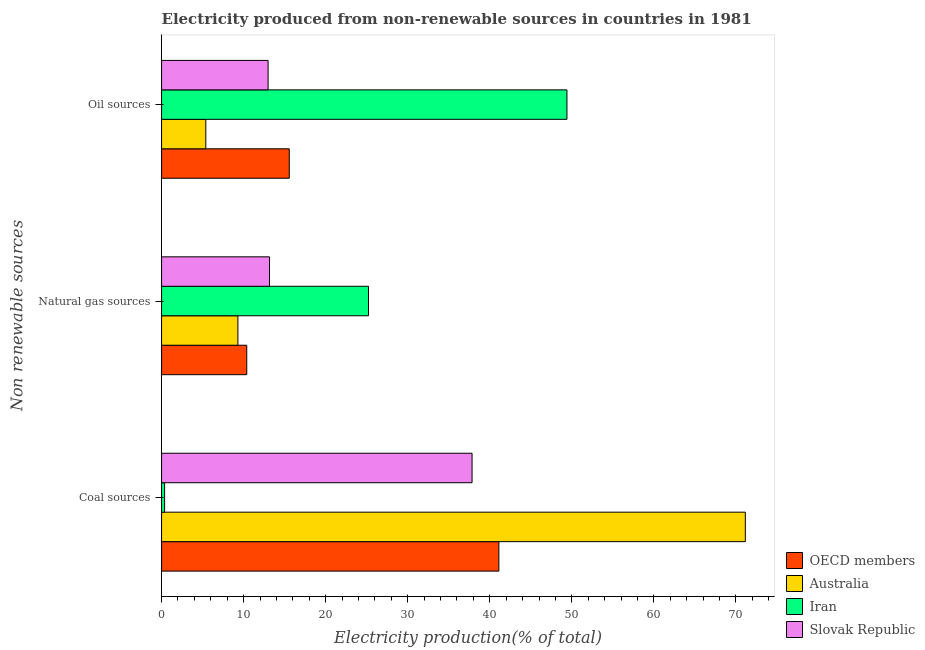How many different coloured bars are there?
Provide a succinct answer. 4. How many groups of bars are there?
Provide a short and direct response. 3. Are the number of bars on each tick of the Y-axis equal?
Ensure brevity in your answer.  Yes. What is the label of the 1st group of bars from the top?
Your answer should be compact. Oil sources. What is the percentage of electricity produced by coal in Slovak Republic?
Keep it short and to the point. 37.84. Across all countries, what is the maximum percentage of electricity produced by oil sources?
Provide a succinct answer. 49.4. Across all countries, what is the minimum percentage of electricity produced by oil sources?
Make the answer very short. 5.39. In which country was the percentage of electricity produced by coal maximum?
Ensure brevity in your answer.  Australia. In which country was the percentage of electricity produced by coal minimum?
Offer a terse response. Iran. What is the total percentage of electricity produced by coal in the graph?
Your answer should be compact. 150.45. What is the difference between the percentage of electricity produced by oil sources in OECD members and that in Australia?
Your answer should be compact. 10.17. What is the difference between the percentage of electricity produced by coal in OECD members and the percentage of electricity produced by natural gas in Australia?
Keep it short and to the point. 31.8. What is the average percentage of electricity produced by natural gas per country?
Give a very brief answer. 14.51. What is the difference between the percentage of electricity produced by oil sources and percentage of electricity produced by natural gas in Slovak Republic?
Keep it short and to the point. -0.17. What is the ratio of the percentage of electricity produced by coal in OECD members to that in Slovak Republic?
Your response must be concise. 1.09. Is the percentage of electricity produced by coal in Slovak Republic less than that in Iran?
Your answer should be very brief. No. What is the difference between the highest and the second highest percentage of electricity produced by oil sources?
Offer a terse response. 33.84. What is the difference between the highest and the lowest percentage of electricity produced by natural gas?
Offer a very short reply. 15.92. How many bars are there?
Make the answer very short. 12. Are all the bars in the graph horizontal?
Offer a terse response. Yes. How many countries are there in the graph?
Your answer should be very brief. 4. Does the graph contain any zero values?
Provide a succinct answer. No. Where does the legend appear in the graph?
Offer a very short reply. Bottom right. How many legend labels are there?
Your answer should be very brief. 4. What is the title of the graph?
Offer a very short reply. Electricity produced from non-renewable sources in countries in 1981. Does "Ethiopia" appear as one of the legend labels in the graph?
Your answer should be compact. No. What is the label or title of the Y-axis?
Your answer should be compact. Non renewable sources. What is the Electricity production(% of total) of OECD members in Coal sources?
Provide a succinct answer. 41.11. What is the Electricity production(% of total) in Australia in Coal sources?
Offer a terse response. 71.14. What is the Electricity production(% of total) of Iran in Coal sources?
Provide a short and direct response. 0.37. What is the Electricity production(% of total) in Slovak Republic in Coal sources?
Your response must be concise. 37.84. What is the Electricity production(% of total) in OECD members in Natural gas sources?
Your answer should be very brief. 10.38. What is the Electricity production(% of total) of Australia in Natural gas sources?
Provide a succinct answer. 9.3. What is the Electricity production(% of total) of Iran in Natural gas sources?
Offer a terse response. 25.22. What is the Electricity production(% of total) of Slovak Republic in Natural gas sources?
Offer a very short reply. 13.15. What is the Electricity production(% of total) in OECD members in Oil sources?
Provide a succinct answer. 15.56. What is the Electricity production(% of total) of Australia in Oil sources?
Offer a very short reply. 5.39. What is the Electricity production(% of total) of Iran in Oil sources?
Your answer should be very brief. 49.4. What is the Electricity production(% of total) of Slovak Republic in Oil sources?
Give a very brief answer. 12.98. Across all Non renewable sources, what is the maximum Electricity production(% of total) of OECD members?
Make the answer very short. 41.11. Across all Non renewable sources, what is the maximum Electricity production(% of total) in Australia?
Make the answer very short. 71.14. Across all Non renewable sources, what is the maximum Electricity production(% of total) of Iran?
Keep it short and to the point. 49.4. Across all Non renewable sources, what is the maximum Electricity production(% of total) in Slovak Republic?
Provide a short and direct response. 37.84. Across all Non renewable sources, what is the minimum Electricity production(% of total) of OECD members?
Offer a terse response. 10.38. Across all Non renewable sources, what is the minimum Electricity production(% of total) of Australia?
Provide a succinct answer. 5.39. Across all Non renewable sources, what is the minimum Electricity production(% of total) in Iran?
Make the answer very short. 0.37. Across all Non renewable sources, what is the minimum Electricity production(% of total) in Slovak Republic?
Provide a short and direct response. 12.98. What is the total Electricity production(% of total) of OECD members in the graph?
Ensure brevity in your answer.  67.05. What is the total Electricity production(% of total) in Australia in the graph?
Keep it short and to the point. 85.83. What is the total Electricity production(% of total) in Iran in the graph?
Offer a terse response. 74.99. What is the total Electricity production(% of total) of Slovak Republic in the graph?
Ensure brevity in your answer.  63.97. What is the difference between the Electricity production(% of total) in OECD members in Coal sources and that in Natural gas sources?
Provide a succinct answer. 30.72. What is the difference between the Electricity production(% of total) in Australia in Coal sources and that in Natural gas sources?
Your response must be concise. 61.84. What is the difference between the Electricity production(% of total) in Iran in Coal sources and that in Natural gas sources?
Keep it short and to the point. -24.85. What is the difference between the Electricity production(% of total) in Slovak Republic in Coal sources and that in Natural gas sources?
Ensure brevity in your answer.  24.68. What is the difference between the Electricity production(% of total) of OECD members in Coal sources and that in Oil sources?
Make the answer very short. 25.54. What is the difference between the Electricity production(% of total) of Australia in Coal sources and that in Oil sources?
Your answer should be very brief. 65.75. What is the difference between the Electricity production(% of total) in Iran in Coal sources and that in Oil sources?
Provide a succinct answer. -49.03. What is the difference between the Electricity production(% of total) in Slovak Republic in Coal sources and that in Oil sources?
Offer a terse response. 24.86. What is the difference between the Electricity production(% of total) in OECD members in Natural gas sources and that in Oil sources?
Provide a succinct answer. -5.18. What is the difference between the Electricity production(% of total) in Australia in Natural gas sources and that in Oil sources?
Keep it short and to the point. 3.91. What is the difference between the Electricity production(% of total) of Iran in Natural gas sources and that in Oil sources?
Your answer should be compact. -24.18. What is the difference between the Electricity production(% of total) in Slovak Republic in Natural gas sources and that in Oil sources?
Keep it short and to the point. 0.17. What is the difference between the Electricity production(% of total) in OECD members in Coal sources and the Electricity production(% of total) in Australia in Natural gas sources?
Make the answer very short. 31.8. What is the difference between the Electricity production(% of total) of OECD members in Coal sources and the Electricity production(% of total) of Iran in Natural gas sources?
Provide a succinct answer. 15.89. What is the difference between the Electricity production(% of total) in OECD members in Coal sources and the Electricity production(% of total) in Slovak Republic in Natural gas sources?
Provide a short and direct response. 27.95. What is the difference between the Electricity production(% of total) in Australia in Coal sources and the Electricity production(% of total) in Iran in Natural gas sources?
Make the answer very short. 45.92. What is the difference between the Electricity production(% of total) in Australia in Coal sources and the Electricity production(% of total) in Slovak Republic in Natural gas sources?
Your answer should be compact. 57.98. What is the difference between the Electricity production(% of total) in Iran in Coal sources and the Electricity production(% of total) in Slovak Republic in Natural gas sources?
Keep it short and to the point. -12.78. What is the difference between the Electricity production(% of total) in OECD members in Coal sources and the Electricity production(% of total) in Australia in Oil sources?
Provide a short and direct response. 35.71. What is the difference between the Electricity production(% of total) of OECD members in Coal sources and the Electricity production(% of total) of Iran in Oil sources?
Provide a succinct answer. -8.3. What is the difference between the Electricity production(% of total) in OECD members in Coal sources and the Electricity production(% of total) in Slovak Republic in Oil sources?
Your response must be concise. 28.12. What is the difference between the Electricity production(% of total) of Australia in Coal sources and the Electricity production(% of total) of Iran in Oil sources?
Your response must be concise. 21.74. What is the difference between the Electricity production(% of total) in Australia in Coal sources and the Electricity production(% of total) in Slovak Republic in Oil sources?
Keep it short and to the point. 58.16. What is the difference between the Electricity production(% of total) in Iran in Coal sources and the Electricity production(% of total) in Slovak Republic in Oil sources?
Ensure brevity in your answer.  -12.61. What is the difference between the Electricity production(% of total) in OECD members in Natural gas sources and the Electricity production(% of total) in Australia in Oil sources?
Make the answer very short. 4.99. What is the difference between the Electricity production(% of total) in OECD members in Natural gas sources and the Electricity production(% of total) in Iran in Oil sources?
Provide a succinct answer. -39.02. What is the difference between the Electricity production(% of total) in OECD members in Natural gas sources and the Electricity production(% of total) in Slovak Republic in Oil sources?
Your answer should be very brief. -2.6. What is the difference between the Electricity production(% of total) in Australia in Natural gas sources and the Electricity production(% of total) in Iran in Oil sources?
Give a very brief answer. -40.1. What is the difference between the Electricity production(% of total) of Australia in Natural gas sources and the Electricity production(% of total) of Slovak Republic in Oil sources?
Your answer should be very brief. -3.68. What is the difference between the Electricity production(% of total) in Iran in Natural gas sources and the Electricity production(% of total) in Slovak Republic in Oil sources?
Give a very brief answer. 12.24. What is the average Electricity production(% of total) of OECD members per Non renewable sources?
Offer a terse response. 22.35. What is the average Electricity production(% of total) of Australia per Non renewable sources?
Your response must be concise. 28.61. What is the average Electricity production(% of total) in Iran per Non renewable sources?
Offer a very short reply. 25. What is the average Electricity production(% of total) in Slovak Republic per Non renewable sources?
Your answer should be compact. 21.32. What is the difference between the Electricity production(% of total) in OECD members and Electricity production(% of total) in Australia in Coal sources?
Your answer should be very brief. -30.03. What is the difference between the Electricity production(% of total) of OECD members and Electricity production(% of total) of Iran in Coal sources?
Provide a succinct answer. 40.74. What is the difference between the Electricity production(% of total) of OECD members and Electricity production(% of total) of Slovak Republic in Coal sources?
Offer a terse response. 3.27. What is the difference between the Electricity production(% of total) in Australia and Electricity production(% of total) in Iran in Coal sources?
Your response must be concise. 70.77. What is the difference between the Electricity production(% of total) of Australia and Electricity production(% of total) of Slovak Republic in Coal sources?
Offer a terse response. 33.3. What is the difference between the Electricity production(% of total) of Iran and Electricity production(% of total) of Slovak Republic in Coal sources?
Your answer should be very brief. -37.47. What is the difference between the Electricity production(% of total) in OECD members and Electricity production(% of total) in Australia in Natural gas sources?
Provide a short and direct response. 1.08. What is the difference between the Electricity production(% of total) in OECD members and Electricity production(% of total) in Iran in Natural gas sources?
Offer a very short reply. -14.84. What is the difference between the Electricity production(% of total) in OECD members and Electricity production(% of total) in Slovak Republic in Natural gas sources?
Ensure brevity in your answer.  -2.77. What is the difference between the Electricity production(% of total) of Australia and Electricity production(% of total) of Iran in Natural gas sources?
Your response must be concise. -15.92. What is the difference between the Electricity production(% of total) in Australia and Electricity production(% of total) in Slovak Republic in Natural gas sources?
Ensure brevity in your answer.  -3.85. What is the difference between the Electricity production(% of total) of Iran and Electricity production(% of total) of Slovak Republic in Natural gas sources?
Your response must be concise. 12.06. What is the difference between the Electricity production(% of total) of OECD members and Electricity production(% of total) of Australia in Oil sources?
Provide a short and direct response. 10.17. What is the difference between the Electricity production(% of total) of OECD members and Electricity production(% of total) of Iran in Oil sources?
Ensure brevity in your answer.  -33.84. What is the difference between the Electricity production(% of total) in OECD members and Electricity production(% of total) in Slovak Republic in Oil sources?
Your response must be concise. 2.58. What is the difference between the Electricity production(% of total) in Australia and Electricity production(% of total) in Iran in Oil sources?
Your answer should be very brief. -44.01. What is the difference between the Electricity production(% of total) of Australia and Electricity production(% of total) of Slovak Republic in Oil sources?
Offer a terse response. -7.59. What is the difference between the Electricity production(% of total) of Iran and Electricity production(% of total) of Slovak Republic in Oil sources?
Provide a succinct answer. 36.42. What is the ratio of the Electricity production(% of total) in OECD members in Coal sources to that in Natural gas sources?
Your response must be concise. 3.96. What is the ratio of the Electricity production(% of total) of Australia in Coal sources to that in Natural gas sources?
Make the answer very short. 7.65. What is the ratio of the Electricity production(% of total) of Iran in Coal sources to that in Natural gas sources?
Your response must be concise. 0.01. What is the ratio of the Electricity production(% of total) of Slovak Republic in Coal sources to that in Natural gas sources?
Your answer should be compact. 2.88. What is the ratio of the Electricity production(% of total) in OECD members in Coal sources to that in Oil sources?
Offer a terse response. 2.64. What is the ratio of the Electricity production(% of total) in Australia in Coal sources to that in Oil sources?
Your answer should be compact. 13.19. What is the ratio of the Electricity production(% of total) of Iran in Coal sources to that in Oil sources?
Your response must be concise. 0.01. What is the ratio of the Electricity production(% of total) of Slovak Republic in Coal sources to that in Oil sources?
Your response must be concise. 2.91. What is the ratio of the Electricity production(% of total) of OECD members in Natural gas sources to that in Oil sources?
Give a very brief answer. 0.67. What is the ratio of the Electricity production(% of total) of Australia in Natural gas sources to that in Oil sources?
Your answer should be very brief. 1.73. What is the ratio of the Electricity production(% of total) of Iran in Natural gas sources to that in Oil sources?
Your answer should be very brief. 0.51. What is the ratio of the Electricity production(% of total) of Slovak Republic in Natural gas sources to that in Oil sources?
Your answer should be very brief. 1.01. What is the difference between the highest and the second highest Electricity production(% of total) of OECD members?
Your answer should be compact. 25.54. What is the difference between the highest and the second highest Electricity production(% of total) in Australia?
Give a very brief answer. 61.84. What is the difference between the highest and the second highest Electricity production(% of total) of Iran?
Ensure brevity in your answer.  24.18. What is the difference between the highest and the second highest Electricity production(% of total) of Slovak Republic?
Offer a very short reply. 24.68. What is the difference between the highest and the lowest Electricity production(% of total) of OECD members?
Offer a very short reply. 30.72. What is the difference between the highest and the lowest Electricity production(% of total) of Australia?
Your response must be concise. 65.75. What is the difference between the highest and the lowest Electricity production(% of total) of Iran?
Make the answer very short. 49.03. What is the difference between the highest and the lowest Electricity production(% of total) of Slovak Republic?
Your response must be concise. 24.86. 